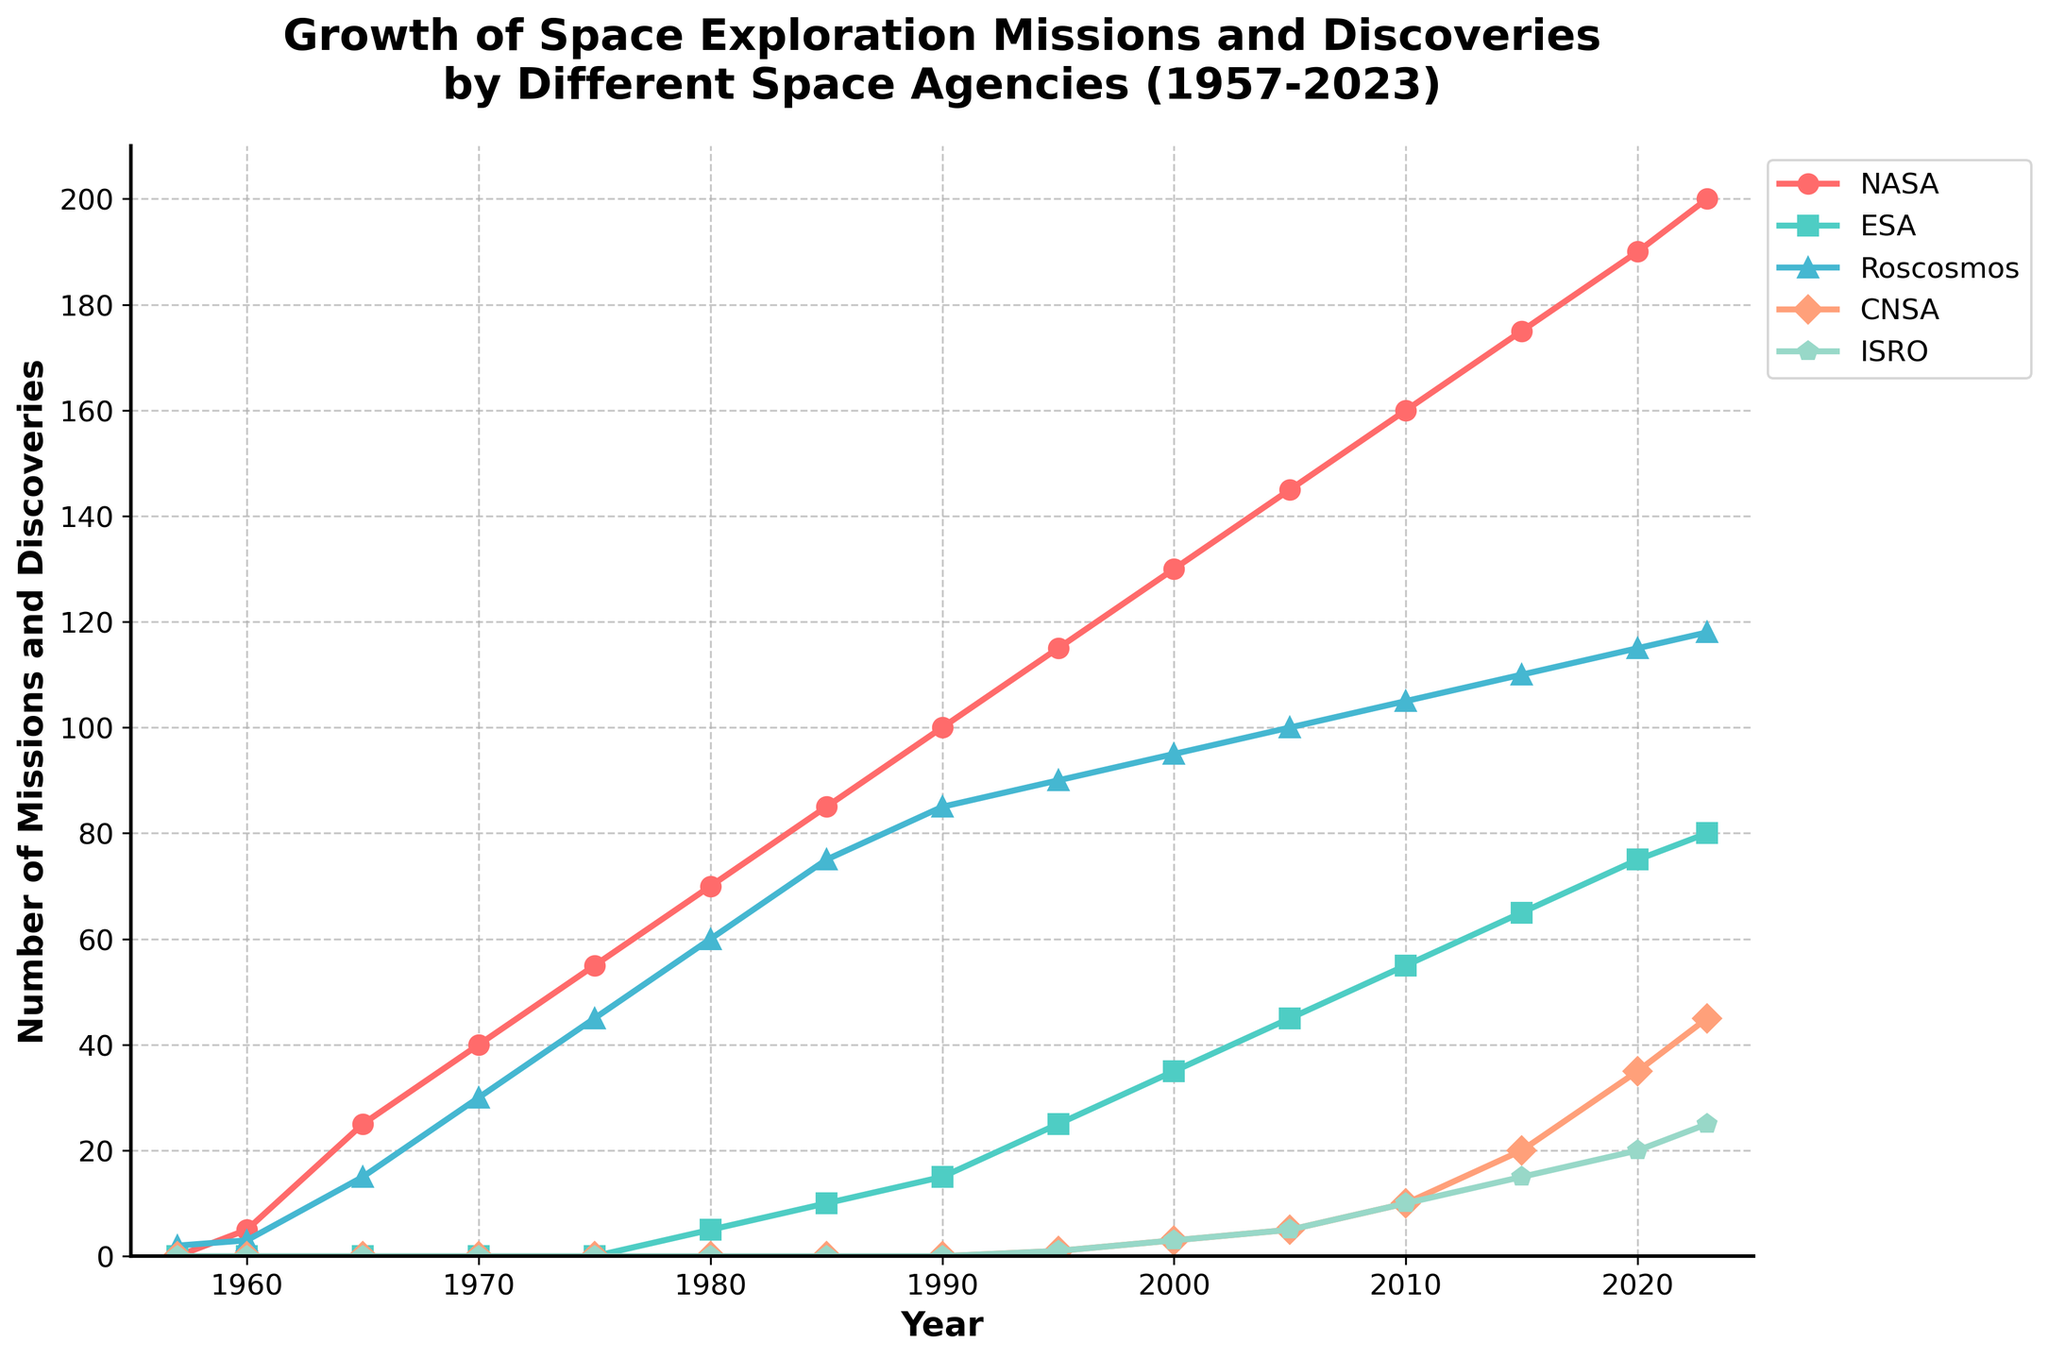What's the total number of missions and discoveries by NASA and ESA combined in 2020? First, identify the number of missions and discoveries by NASA and ESA in 2020 from the chart. NASA has 190 and ESA has 75. Add these values together: 190 + 75 = 265
Answer: 265 Between 1970 and 1990, which space agency reported the greatest increase in missions and discoveries? Identify the values in 1970 and 1990 for each agency. Calculate the difference for each: NASA (100 - 40 = 60), Roscosmos (85 - 30 = 55). Roscosmos exhibits the greatest increase.
Answer: NASA Which agency had the least growth in space exploration between 2000 and 2023? Calculate the difference between 2023 and 2000 for each agency: NASA (200-130 = 70), ESA (80-35 = 45), Roscosmos (118-95 = 23), CNSA (45-3 = 42), ISRO (25-3 = 22). ISRO has the least growth with an increase of 22
Answer: ISRO What is the approximate slope of NASA's growth trend from 1995 to 2023? Between 1995 (115 missions) and 2023 (200 missions), the number of years is 2023 - 1995 = 28. The slope is (200 - 115) / 28 = 85 / 28 ≈ 3.04
Answer: 3.04 By visual inspection, which agencies had no missions or discoveries before 1980? Look at the visual attributes of the lines: ESA, CNSA, and ISRO all show flat lines at zero until after 1980.
Answer: ESA, CNSA, ISRO In which year did CNSA surpass 30 missions and discoveries? On the plot, identify the year where CNSA's line crosses above 30 missions. This point occurs at 2015.
Answer: 2015 How many years did it take for ISRO to go from its first 5 missions to 25 missions? ISRO had 5 missions in 2005 and reached 25 in 2023, taking 2023 − 2005 = 18 years.
Answer: 18 Which agency had more missions in 1995, ESA or ISRO, and by how much? In 1995, ESA had 25 missions and ISRO had 1. The difference is 25 - 1 = 24. ESA had 24 more missions than ISRO.
Answer: ESA by 24 